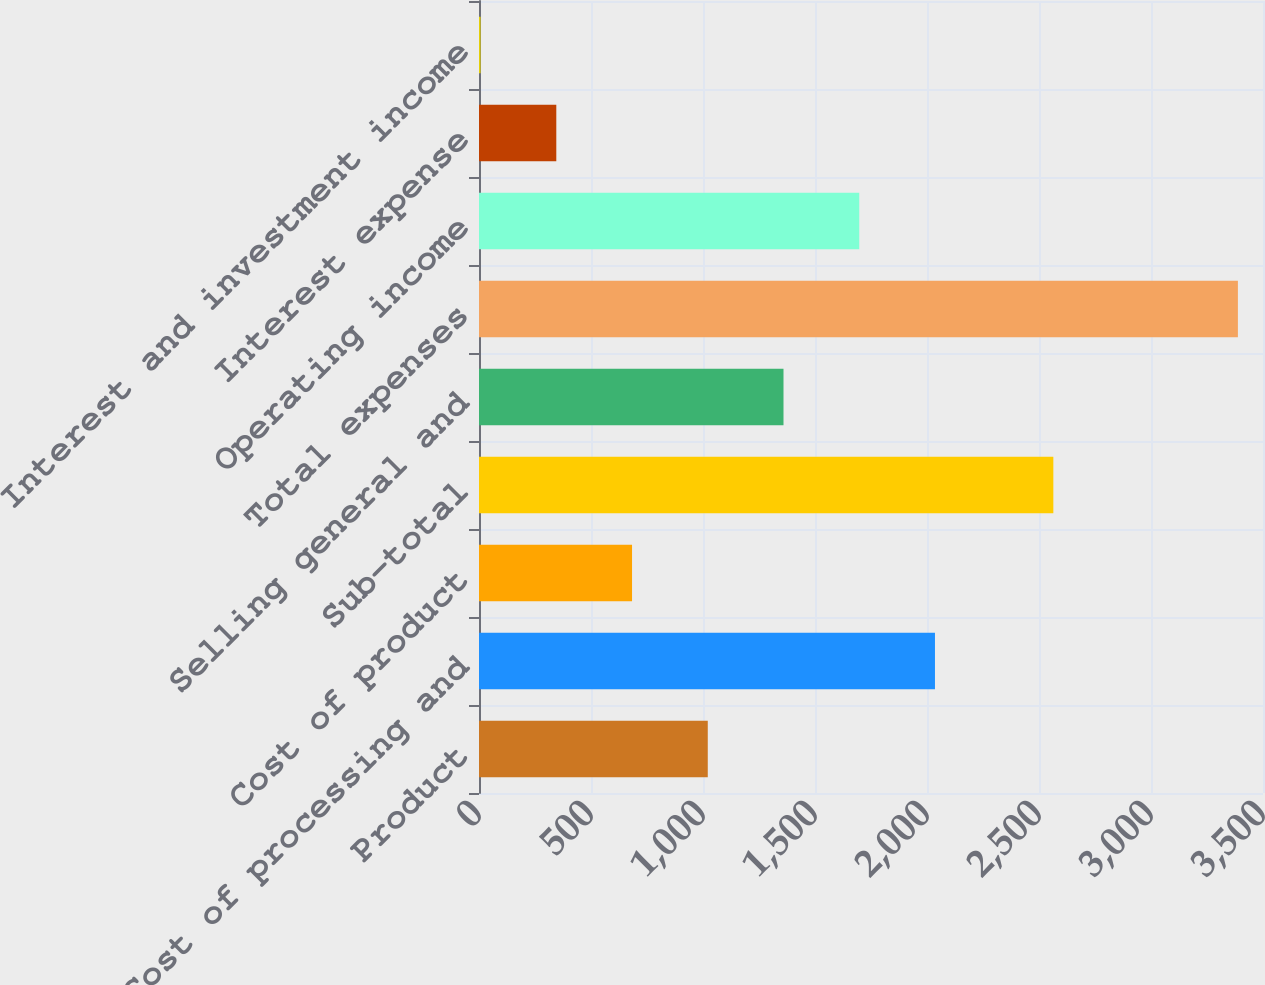Convert chart. <chart><loc_0><loc_0><loc_500><loc_500><bar_chart><fcel>Product<fcel>Cost of processing and<fcel>Cost of product<fcel>Sub-total<fcel>Selling general and<fcel>Total expenses<fcel>Operating income<fcel>Interest expense<fcel>Interest and investment income<nl><fcel>1021.3<fcel>2035.6<fcel>683.2<fcel>2564<fcel>1359.4<fcel>3388<fcel>1697.5<fcel>345.1<fcel>7<nl></chart> 